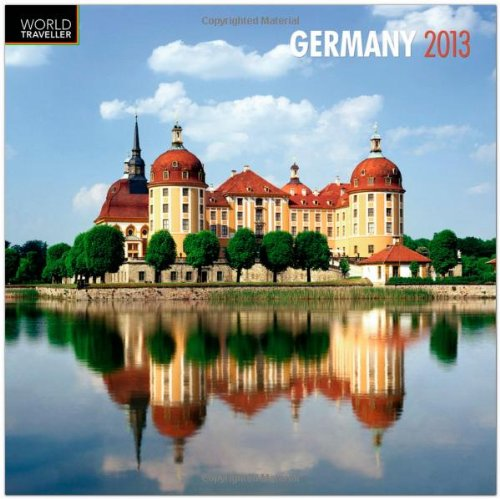Who is the author of this book? BrownTrout Publishers, known for their extensive collection of quality calendars, is the publishing company behind this calendar. 